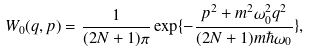<formula> <loc_0><loc_0><loc_500><loc_500>W _ { 0 } ( q , p ) = { \frac { 1 } { ( 2 N + 1 ) \pi } } \exp \{ - { \frac { p ^ { 2 } + m ^ { 2 } \omega ^ { 2 } _ { 0 } q ^ { 2 } } { ( 2 N + 1 ) m \hbar { \omega } _ { 0 } } } \} ,</formula> 